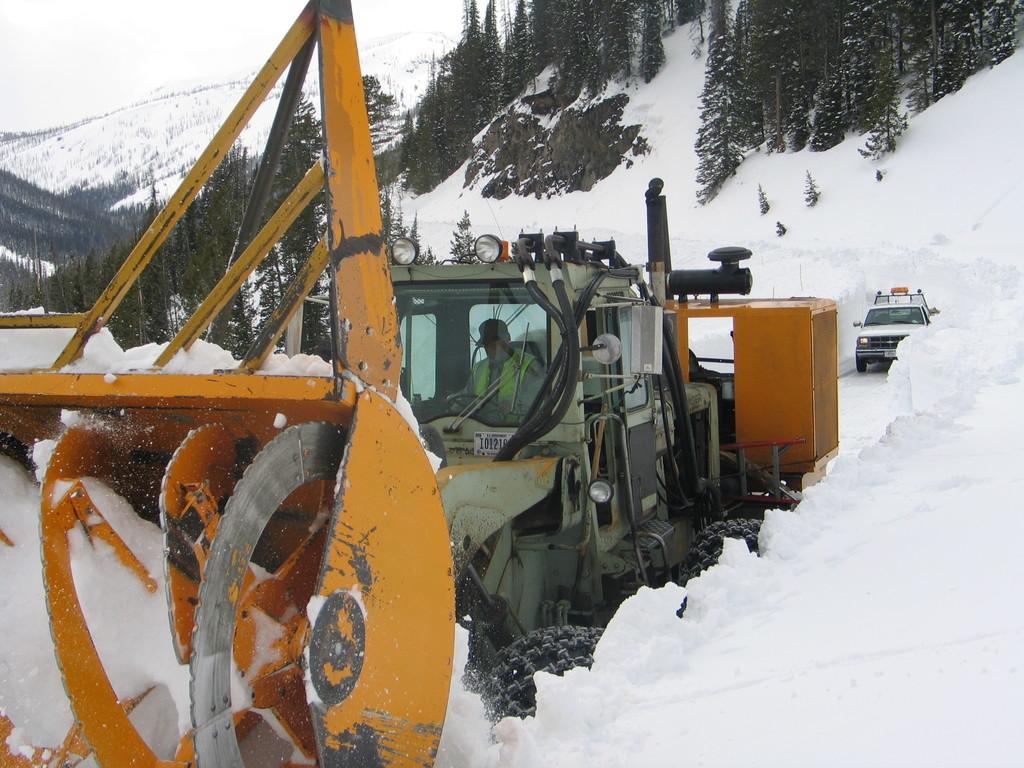Describe this image in one or two sentences. In this image I can see two vehicles are on the snow. These vehicles are in different color I can see one person inside the vehicle. To the side of the vehicle there are many trees and the sky. 